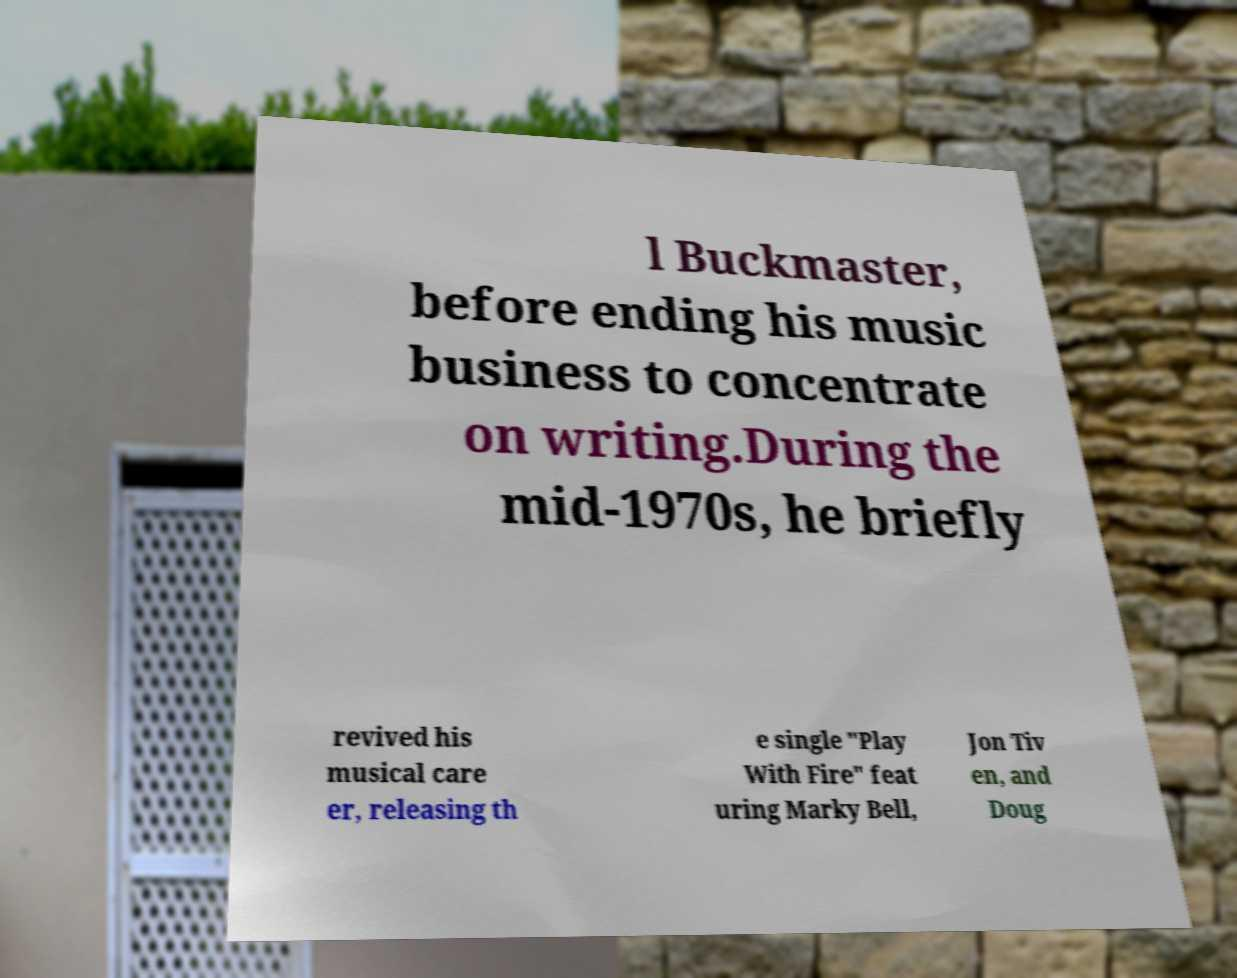What messages or text are displayed in this image? I need them in a readable, typed format. l Buckmaster, before ending his music business to concentrate on writing.During the mid-1970s, he briefly revived his musical care er, releasing th e single "Play With Fire" feat uring Marky Bell, Jon Tiv en, and Doug 